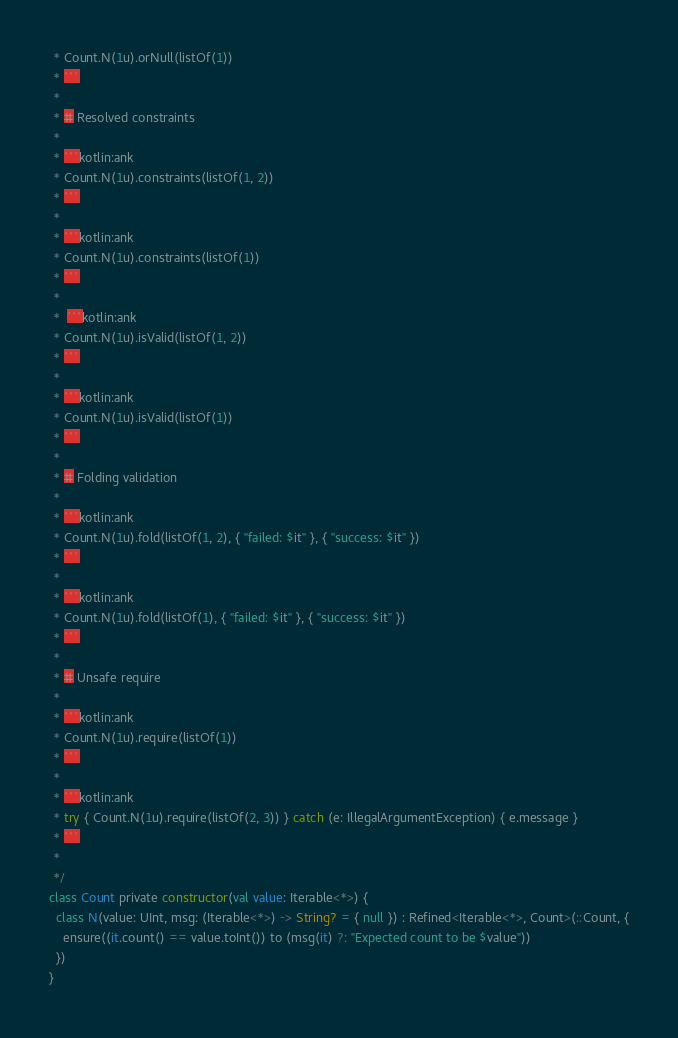Convert code to text. <code><loc_0><loc_0><loc_500><loc_500><_Kotlin_> * Count.N(1u).orNull(listOf(1))
 * ```
 *
 * # Resolved constraints
 *
 * ```kotlin:ank
 * Count.N(1u).constraints(listOf(1, 2))
 * ```
 *
 * ```kotlin:ank
 * Count.N(1u).constraints(listOf(1))
 * ```
 *
 *  ```kotlin:ank
 * Count.N(1u).isValid(listOf(1, 2))
 * ```
 *
 * ```kotlin:ank
 * Count.N(1u).isValid(listOf(1))
 * ```
 *
 * # Folding validation
 *
 * ```kotlin:ank
 * Count.N(1u).fold(listOf(1, 2), { "failed: $it" }, { "success: $it" })
 * ```
 *
 * ```kotlin:ank
 * Count.N(1u).fold(listOf(1), { "failed: $it" }, { "success: $it" })
 * ```
 *
 * # Unsafe require
 *
 * ```kotlin:ank
 * Count.N(1u).require(listOf(1))
 * ```
 *
 * ```kotlin:ank
 * try { Count.N(1u).require(listOf(2, 3)) } catch (e: IllegalArgumentException) { e.message }
 * ```
 *
 */
class Count private constructor(val value: Iterable<*>) {
  class N(value: UInt, msg: (Iterable<*>) -> String? = { null }) : Refined<Iterable<*>, Count>(::Count, {
    ensure((it.count() == value.toInt()) to (msg(it) ?: "Expected count to be $value"))
  })
}</code> 